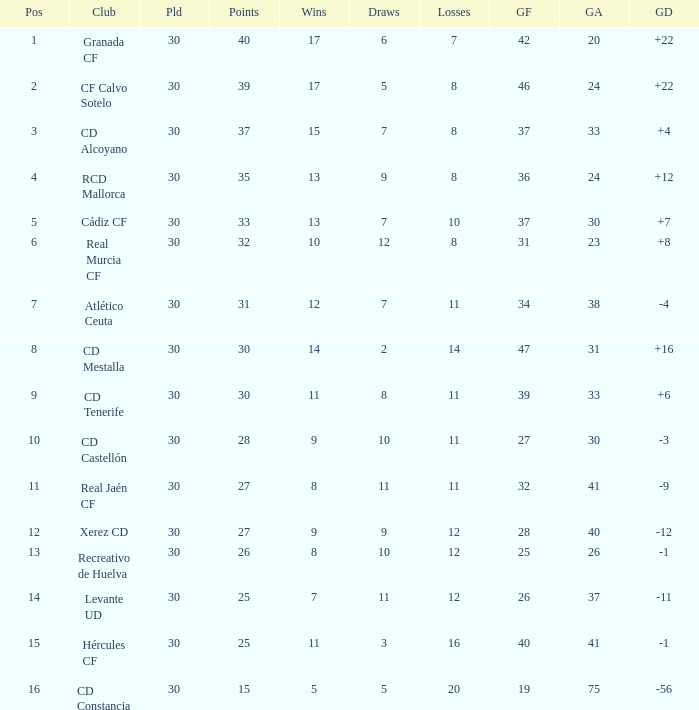How many Draws have 30 Points, and less than 33 Goals against? 1.0. 